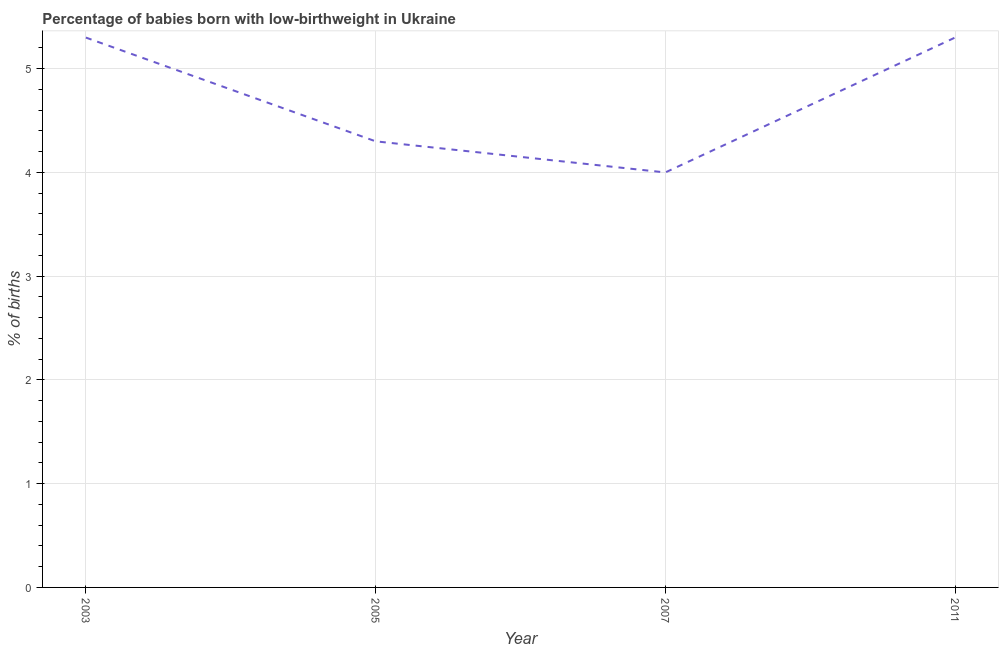Across all years, what is the maximum percentage of babies who were born with low-birthweight?
Give a very brief answer. 5.3. What is the difference between the percentage of babies who were born with low-birthweight in 2007 and 2011?
Offer a very short reply. -1.3. What is the average percentage of babies who were born with low-birthweight per year?
Provide a succinct answer. 4.72. What is the median percentage of babies who were born with low-birthweight?
Offer a very short reply. 4.8. In how many years, is the percentage of babies who were born with low-birthweight greater than 2.8 %?
Provide a short and direct response. 4. What is the ratio of the percentage of babies who were born with low-birthweight in 2003 to that in 2005?
Offer a very short reply. 1.23. Is the percentage of babies who were born with low-birthweight in 2003 less than that in 2005?
Your answer should be very brief. No. Is the difference between the percentage of babies who were born with low-birthweight in 2003 and 2007 greater than the difference between any two years?
Keep it short and to the point. Yes. What is the difference between the highest and the second highest percentage of babies who were born with low-birthweight?
Your answer should be compact. 0. What is the difference between the highest and the lowest percentage of babies who were born with low-birthweight?
Ensure brevity in your answer.  1.3. In how many years, is the percentage of babies who were born with low-birthweight greater than the average percentage of babies who were born with low-birthweight taken over all years?
Offer a very short reply. 2. Does the percentage of babies who were born with low-birthweight monotonically increase over the years?
Your response must be concise. No. What is the difference between two consecutive major ticks on the Y-axis?
Give a very brief answer. 1. Are the values on the major ticks of Y-axis written in scientific E-notation?
Offer a very short reply. No. Does the graph contain any zero values?
Offer a very short reply. No. What is the title of the graph?
Ensure brevity in your answer.  Percentage of babies born with low-birthweight in Ukraine. What is the label or title of the X-axis?
Your answer should be compact. Year. What is the label or title of the Y-axis?
Your answer should be compact. % of births. What is the % of births in 2003?
Offer a terse response. 5.3. What is the % of births of 2005?
Offer a very short reply. 4.3. What is the difference between the % of births in 2005 and 2007?
Ensure brevity in your answer.  0.3. What is the ratio of the % of births in 2003 to that in 2005?
Your answer should be compact. 1.23. What is the ratio of the % of births in 2003 to that in 2007?
Give a very brief answer. 1.32. What is the ratio of the % of births in 2005 to that in 2007?
Keep it short and to the point. 1.07. What is the ratio of the % of births in 2005 to that in 2011?
Offer a terse response. 0.81. What is the ratio of the % of births in 2007 to that in 2011?
Your answer should be very brief. 0.76. 